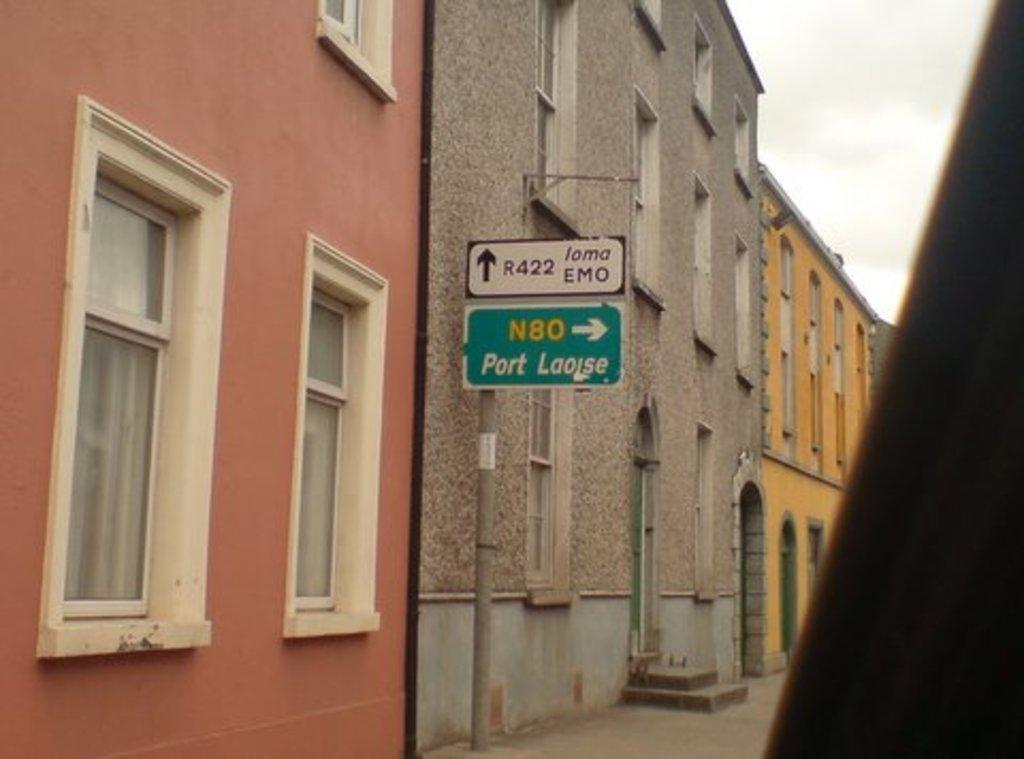What is attached to the pole in the image? There are boards attached to a pole in the image. What can be seen in the distance behind the pole? There are buildings visible in the background of the image. What is visible at the top of the image? The sky is visible at the top of the image. What type of appliance is being used by the tramp in the image? There is no tramp or appliance present in the image. 